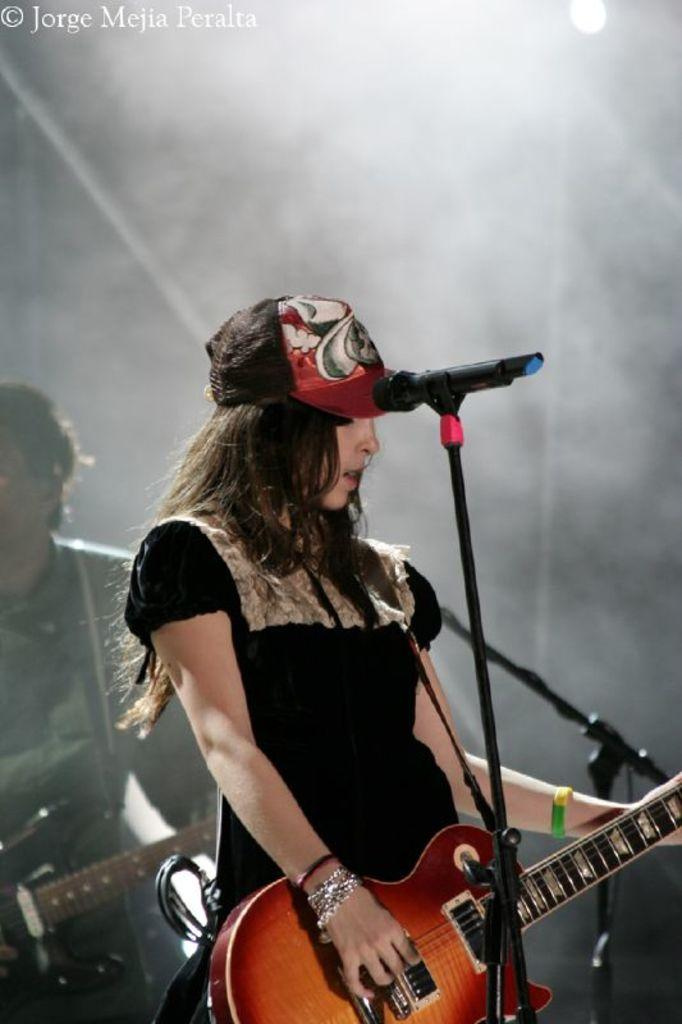Who is the main subject in the image? There is a woman in the image. What is the woman doing in the image? The woman is standing in front of a mic and holding a guitar. Can you describe the person in the background of the image? The person in the background is holding a guitar. What type of monkey can be seen playing the guitar in the image? There is no monkey present in the image, and therefore no such activity can be observed. Can you describe the romantic interaction between the woman and the person in the background? There is no romantic interaction depicted in the image; the woman and the person in the background are both holding guitars. 